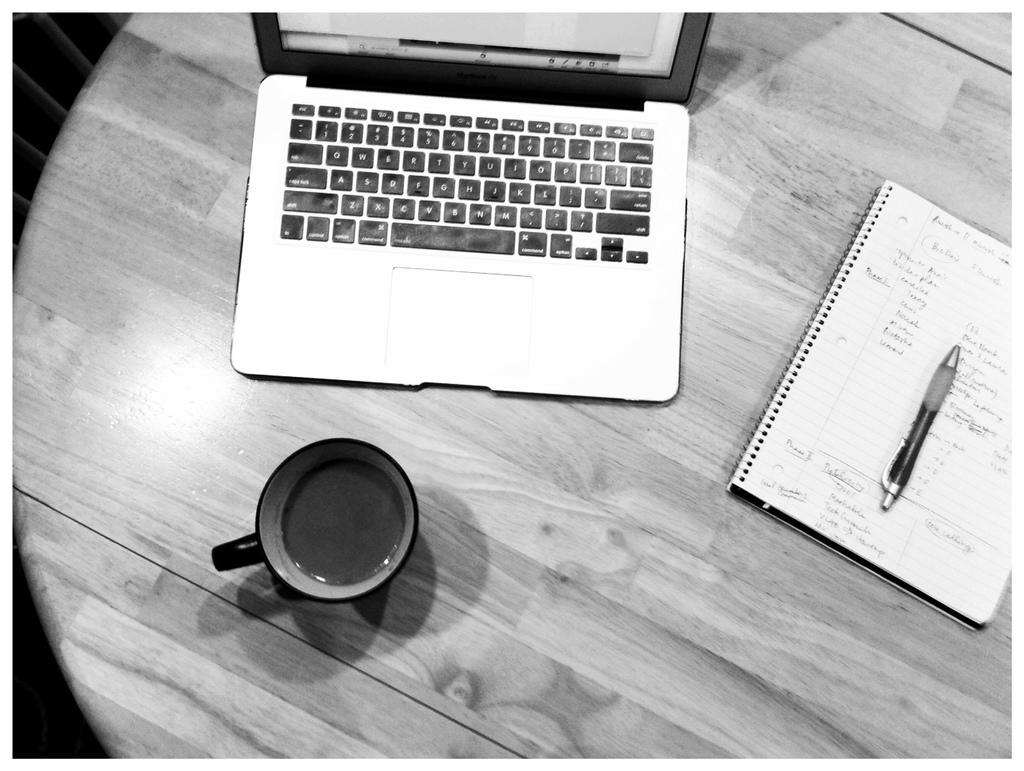What electronic device is on the table in the image? There is a laptop on the table in the image. What is placed in front of the laptop? There is a coffee cup in front of the laptop. What other objects are near the laptop? There is a book with a pen on it beside the laptop. What type of meat is being served in the image? There is no meat present in the image; it features a laptop, a coffee cup, a book, and a pen. 